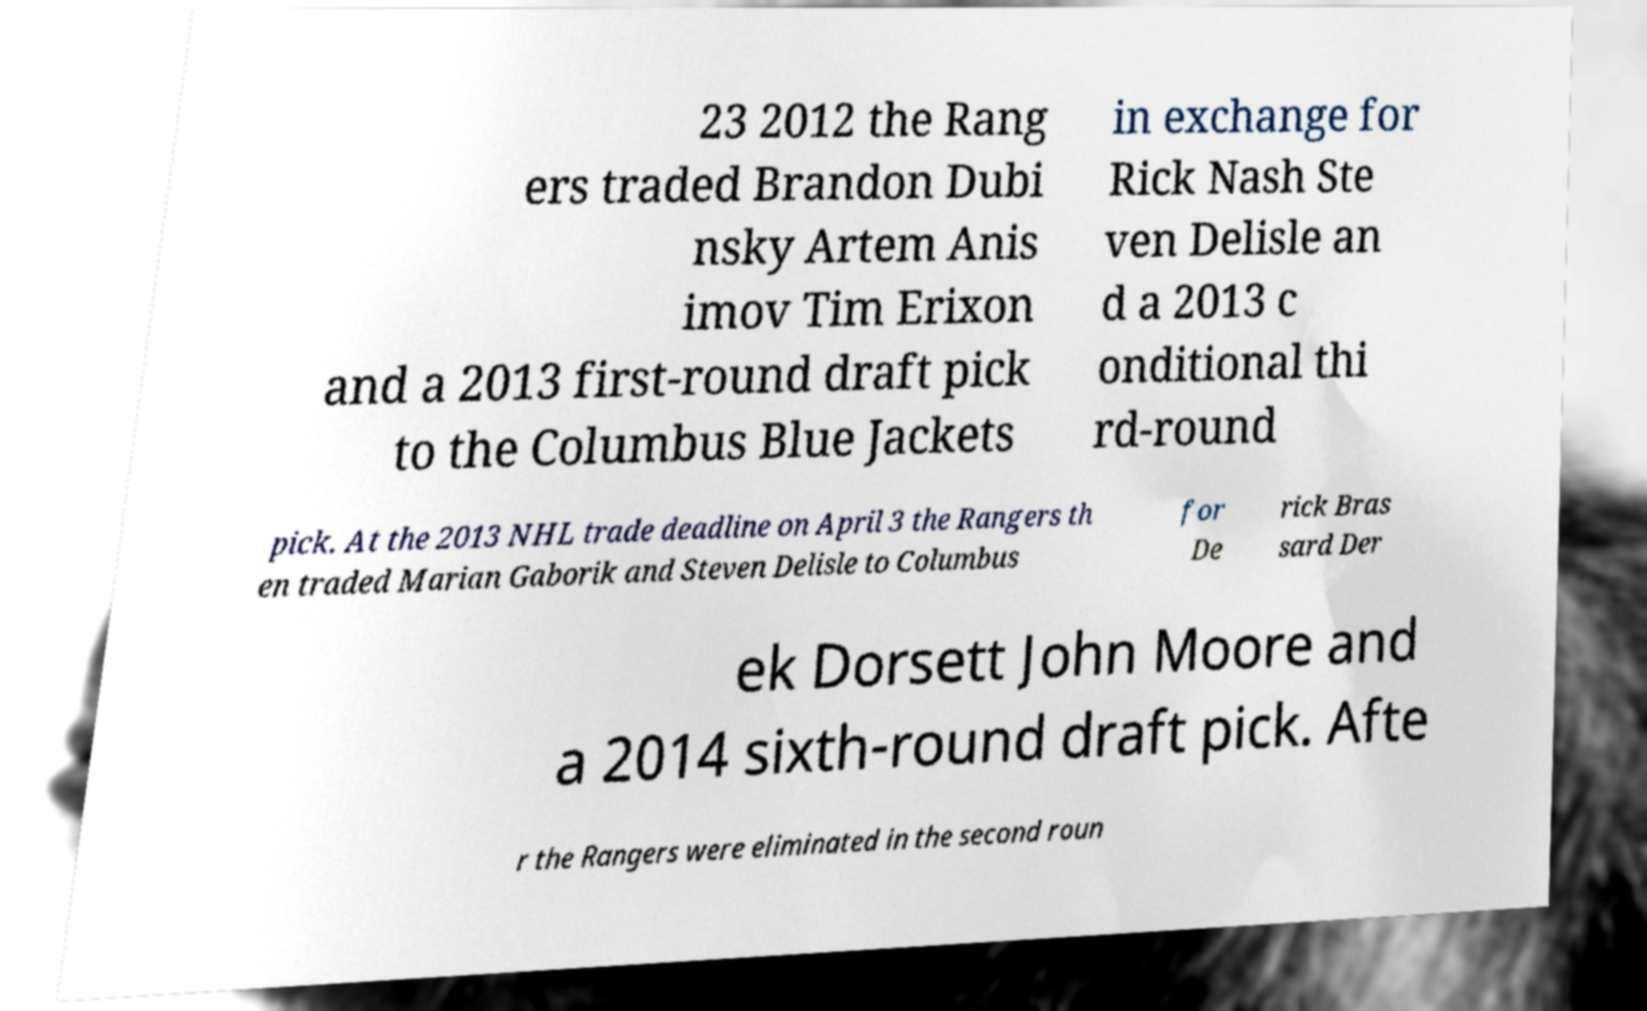Please identify and transcribe the text found in this image. 23 2012 the Rang ers traded Brandon Dubi nsky Artem Anis imov Tim Erixon and a 2013 first-round draft pick to the Columbus Blue Jackets in exchange for Rick Nash Ste ven Delisle an d a 2013 c onditional thi rd-round pick. At the 2013 NHL trade deadline on April 3 the Rangers th en traded Marian Gaborik and Steven Delisle to Columbus for De rick Bras sard Der ek Dorsett John Moore and a 2014 sixth-round draft pick. Afte r the Rangers were eliminated in the second roun 